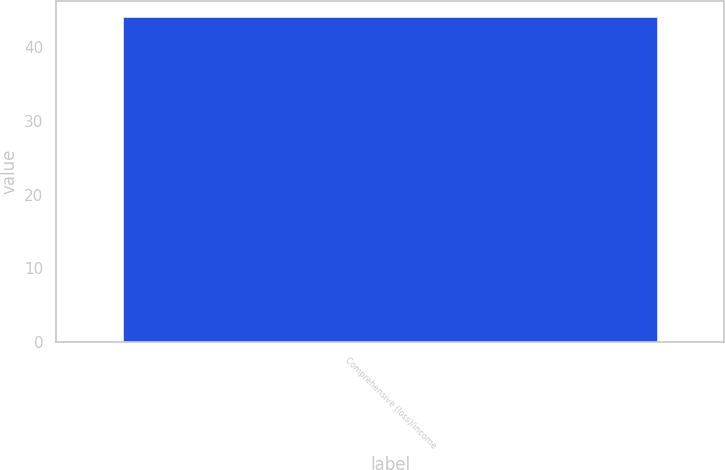Convert chart. <chart><loc_0><loc_0><loc_500><loc_500><bar_chart><fcel>Comprehensive (loss)/income<nl><fcel>44<nl></chart> 